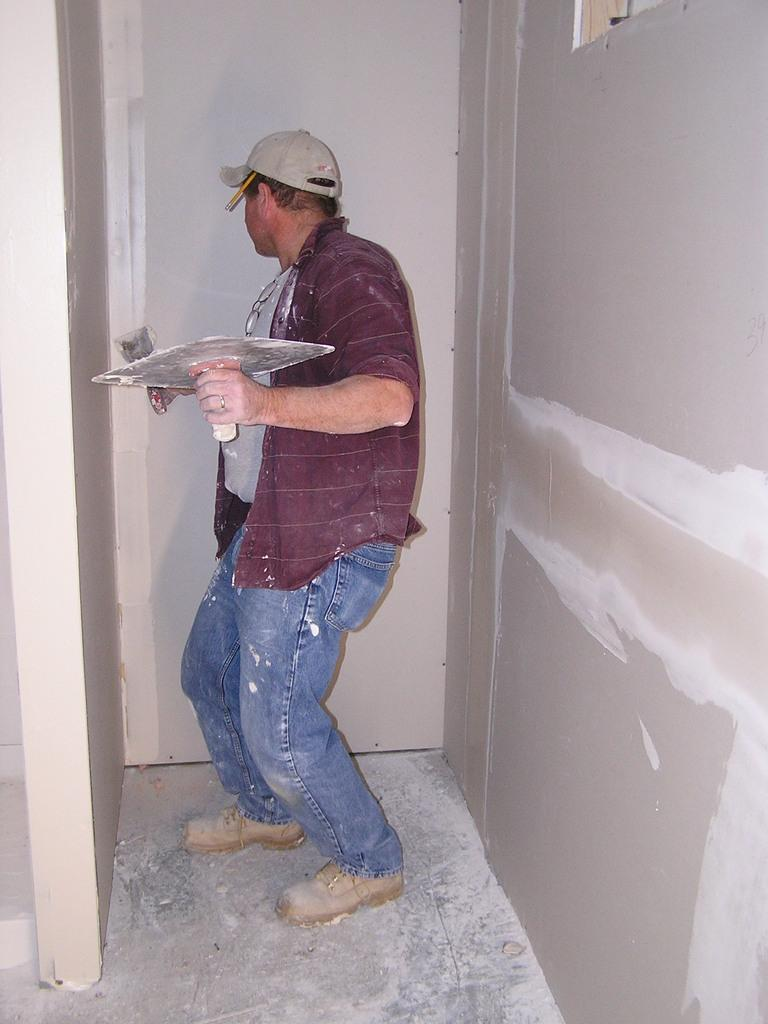What is the main subject of the image? There is a person standing in the image. What is the person holding in his hands? The person is holding two objects in his hands. Can you describe the color of the wall in the image? The wall in the image is light grey in color. Is there a bear using a toothbrush at the party in the image? There is no bear, toothbrush, or party present in the image. 